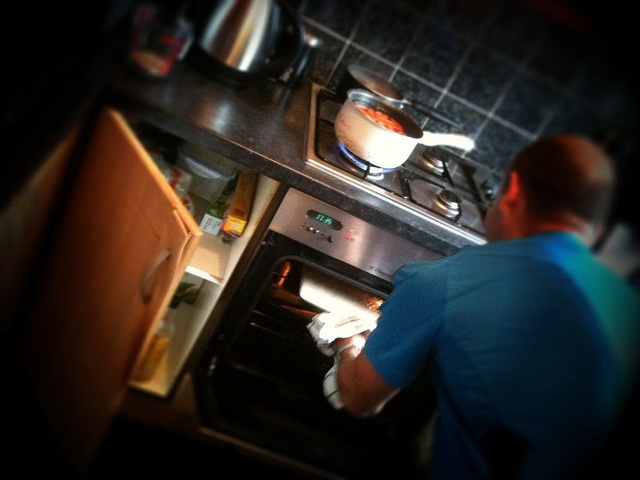Describe the objects in this image and their specific colors. I can see people in black, darkblue, blue, and maroon tones, oven in black, gray, and white tones, oven in black, ivory, maroon, and gray tones, and bottle in black, maroon, and brown tones in this image. 